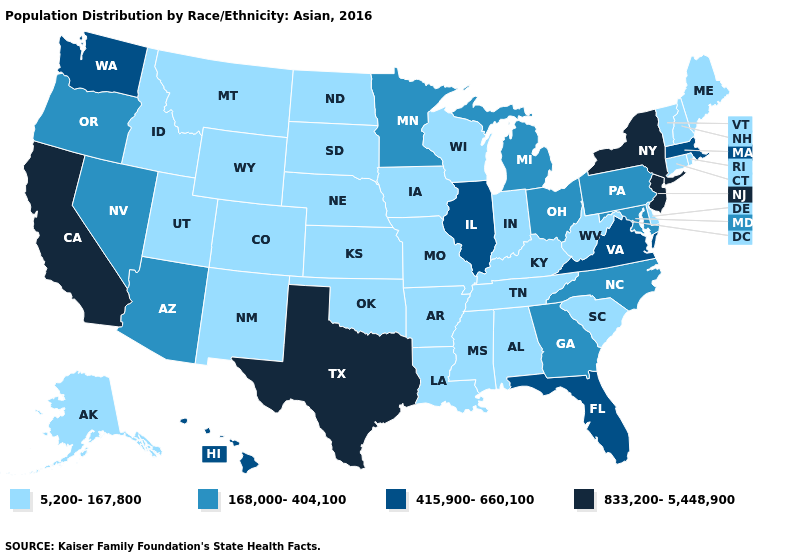Name the states that have a value in the range 415,900-660,100?
Concise answer only. Florida, Hawaii, Illinois, Massachusetts, Virginia, Washington. Does Massachusetts have a lower value than California?
Answer briefly. Yes. Does the first symbol in the legend represent the smallest category?
Short answer required. Yes. Among the states that border Georgia , which have the lowest value?
Give a very brief answer. Alabama, South Carolina, Tennessee. Name the states that have a value in the range 168,000-404,100?
Concise answer only. Arizona, Georgia, Maryland, Michigan, Minnesota, Nevada, North Carolina, Ohio, Oregon, Pennsylvania. What is the value of South Carolina?
Keep it brief. 5,200-167,800. Among the states that border New York , which have the highest value?
Write a very short answer. New Jersey. Name the states that have a value in the range 5,200-167,800?
Short answer required. Alabama, Alaska, Arkansas, Colorado, Connecticut, Delaware, Idaho, Indiana, Iowa, Kansas, Kentucky, Louisiana, Maine, Mississippi, Missouri, Montana, Nebraska, New Hampshire, New Mexico, North Dakota, Oklahoma, Rhode Island, South Carolina, South Dakota, Tennessee, Utah, Vermont, West Virginia, Wisconsin, Wyoming. What is the value of Iowa?
Keep it brief. 5,200-167,800. Among the states that border Arkansas , does Texas have the lowest value?
Be succinct. No. Which states have the lowest value in the MidWest?
Write a very short answer. Indiana, Iowa, Kansas, Missouri, Nebraska, North Dakota, South Dakota, Wisconsin. Name the states that have a value in the range 168,000-404,100?
Give a very brief answer. Arizona, Georgia, Maryland, Michigan, Minnesota, Nevada, North Carolina, Ohio, Oregon, Pennsylvania. Which states have the highest value in the USA?
Quick response, please. California, New Jersey, New York, Texas. What is the value of New York?
Give a very brief answer. 833,200-5,448,900. What is the value of Ohio?
Answer briefly. 168,000-404,100. 